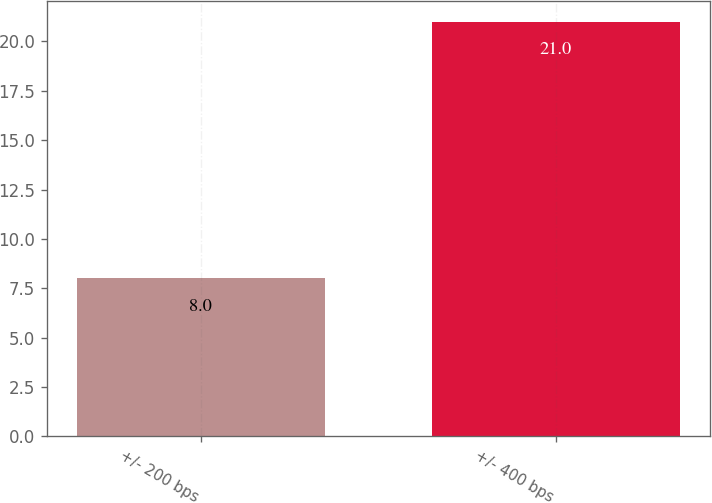<chart> <loc_0><loc_0><loc_500><loc_500><bar_chart><fcel>+/- 200 bps<fcel>+/- 400 bps<nl><fcel>8<fcel>21<nl></chart> 